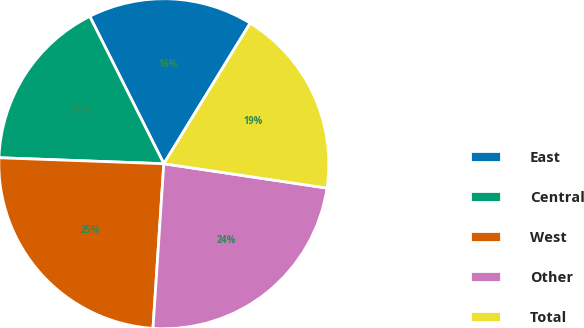Convert chart to OTSL. <chart><loc_0><loc_0><loc_500><loc_500><pie_chart><fcel>East<fcel>Central<fcel>West<fcel>Other<fcel>Total<nl><fcel>16.18%<fcel>17.01%<fcel>24.53%<fcel>23.69%<fcel>18.59%<nl></chart> 